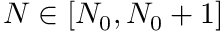Convert formula to latex. <formula><loc_0><loc_0><loc_500><loc_500>N \in [ N _ { 0 } , N _ { 0 } + 1 ]</formula> 